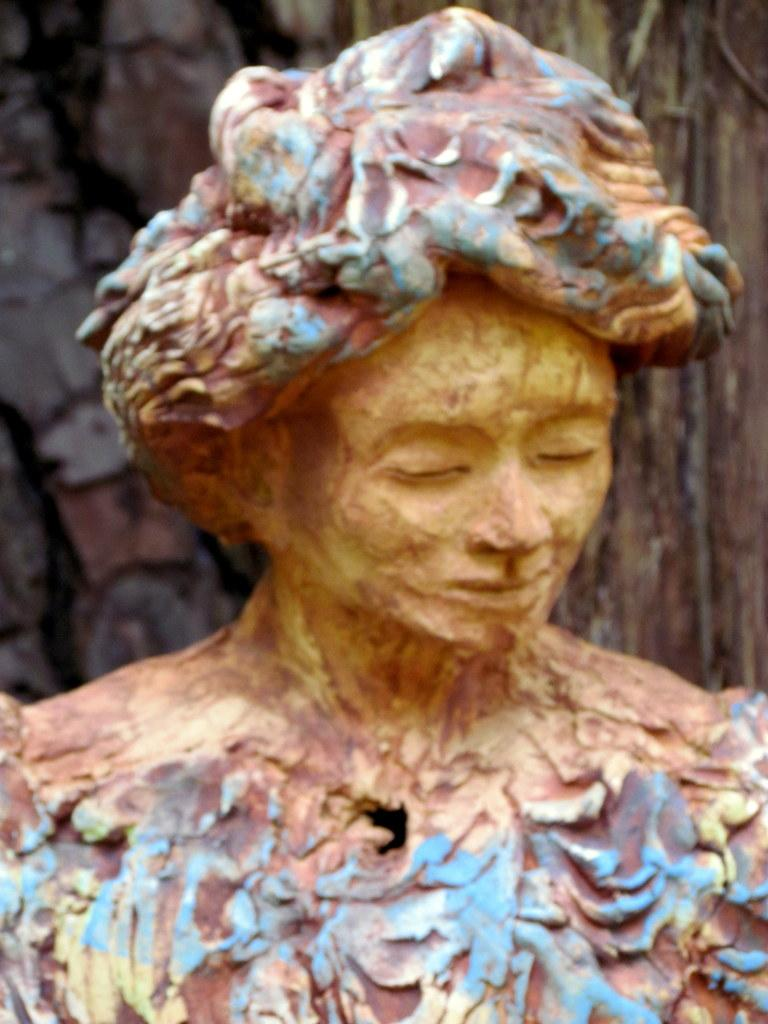What is the main subject of the image? There is a statue in the image. What type of quiver is the dog carrying in the image? There is no dog or quiver present in the image; it features a statue. What kind of pet is shown interacting with the statue in the image? There is no pet present in the image; it features a statue. 